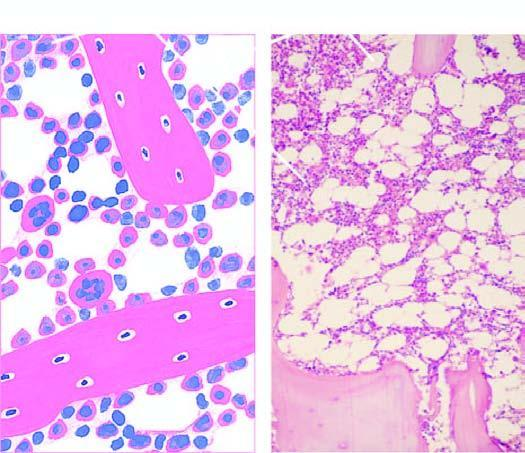do the circle shown with red line support the marrow-containing tissue?
Answer the question using a single word or phrase. No 